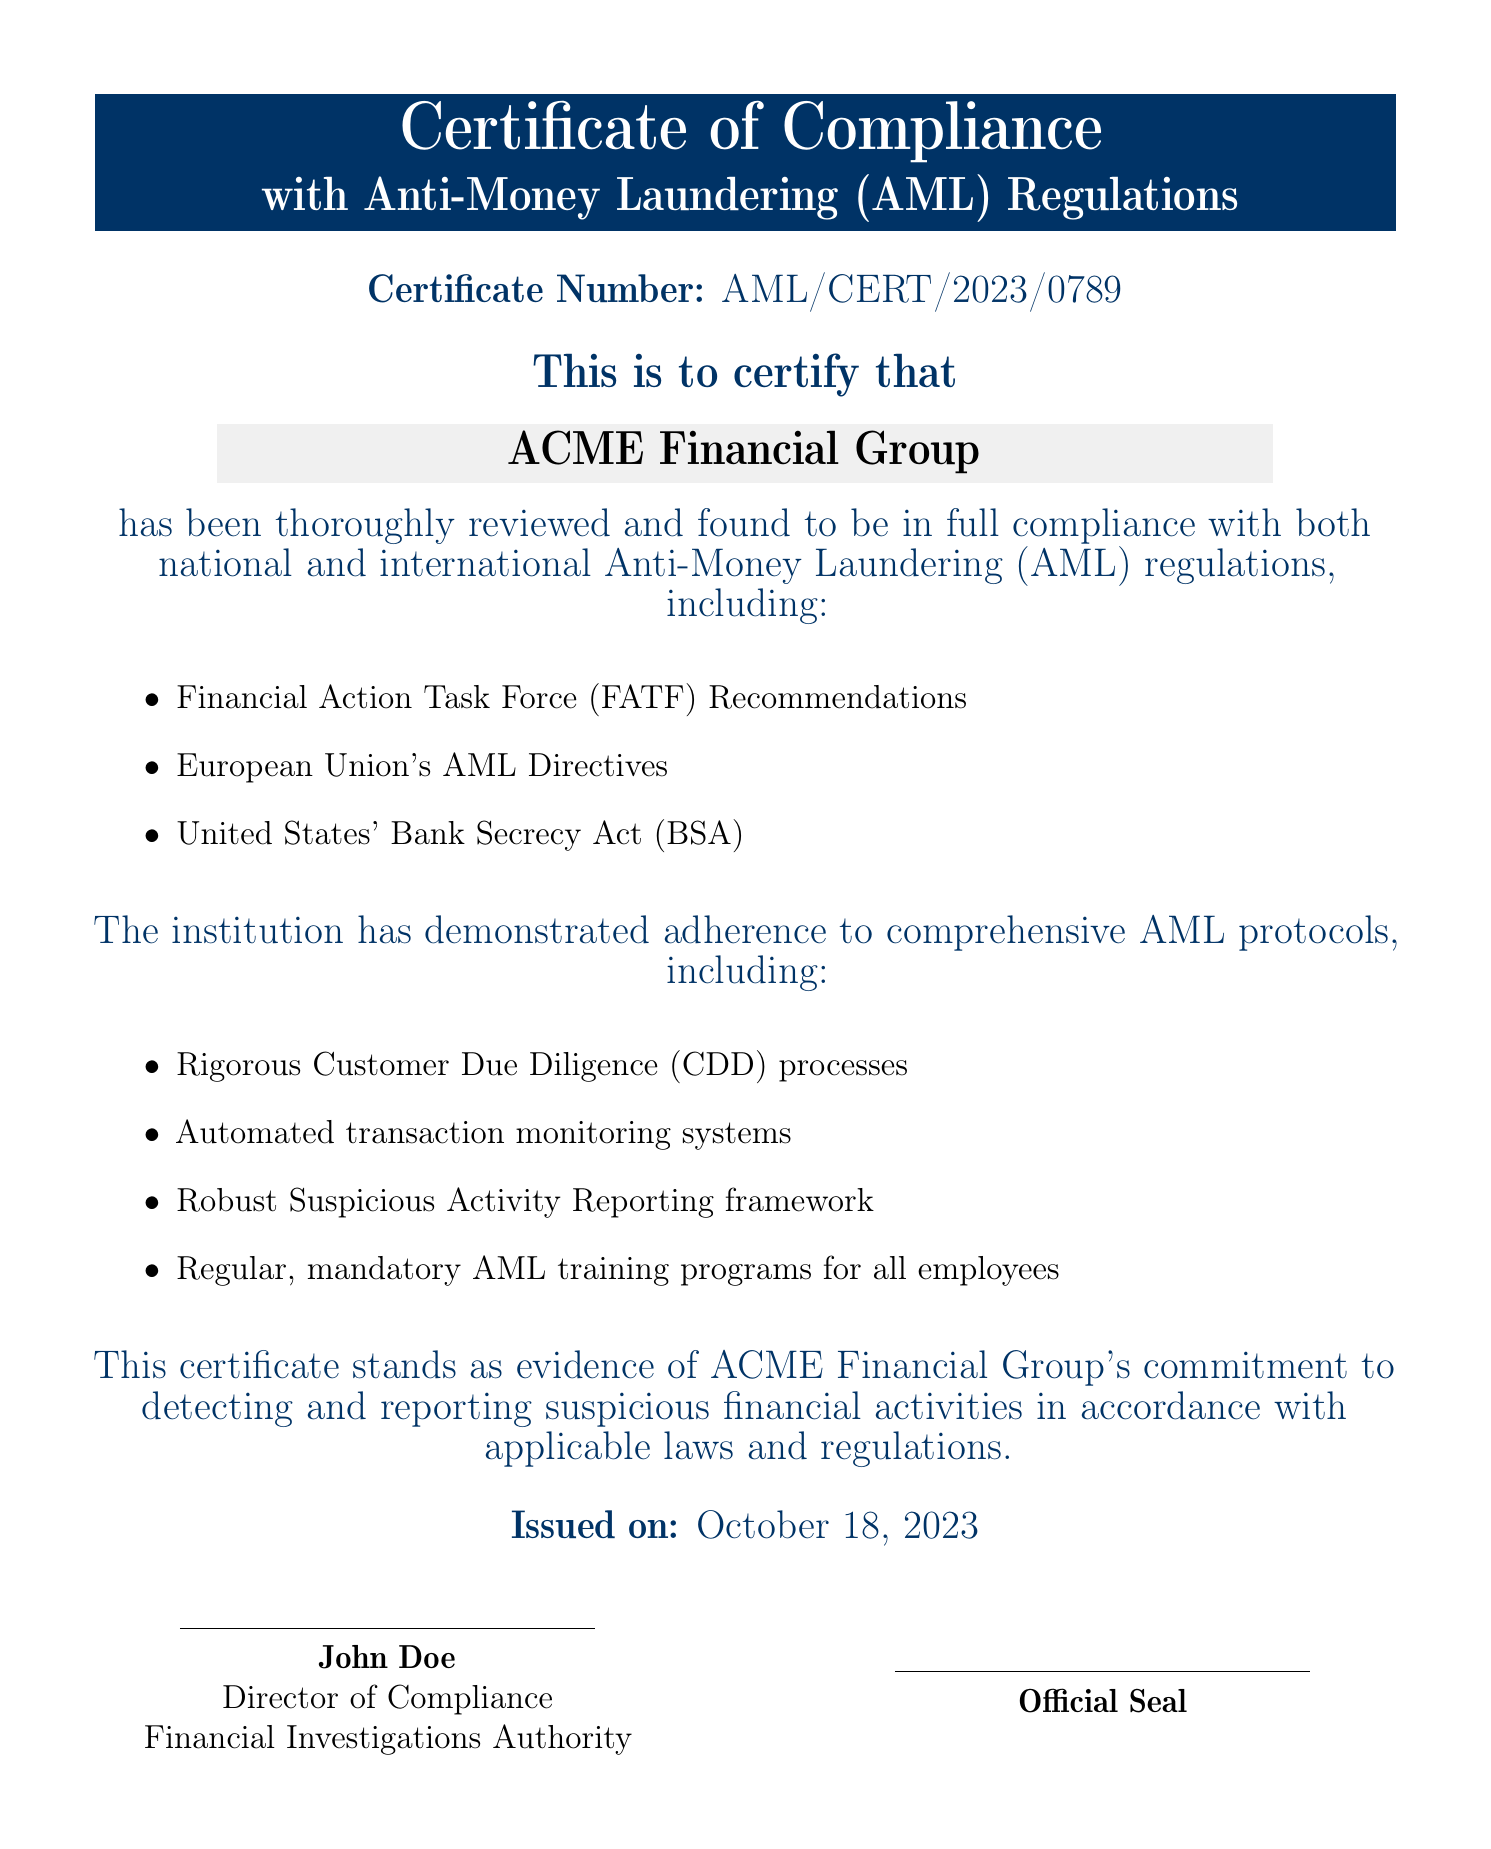What is the certificate number? The certificate number is a unique identifier specified in the document, which is AML/CERT/2023/0789.
Answer: AML/CERT/2023/0789 Who issued the certificate? The issuer is mentioned near the end of the document, identified as John Doe, who holds the position of Director of Compliance.
Answer: John Doe What institution is certified? The name of the institution that has received the certificate is highlighted in the document, which is ACME Financial Group.
Answer: ACME Financial Group What date was the certificate issued? The issuance date is provided clearly in the document, stated as October 18, 2023.
Answer: October 18, 2023 What regulation does the certificate confirm compliance with? The document lists multiple regulations; one prominent example is the Financial Action Task Force (FATF) Recommendations.
Answer: Financial Action Task Force (FATF) Recommendations What is one measure taken for AML compliance? The document specifies several measures; one such measure is the implementation of rigorous Customer Due Diligence (CDD) processes.
Answer: Rigorous Customer Due Diligence (CDD) processes What type of training is mandated for employees? The document indicates that mandatory AML training programs are required for all employees to ensure compliance.
Answer: Mandatory AML training programs What is the purpose of this certificate? The primary purpose of the certificate, as stated, is to serve as evidence of the institution's commitment to detecting and reporting suspicious financial activities.
Answer: Evidence of commitment to detecting and reporting suspicious activities 